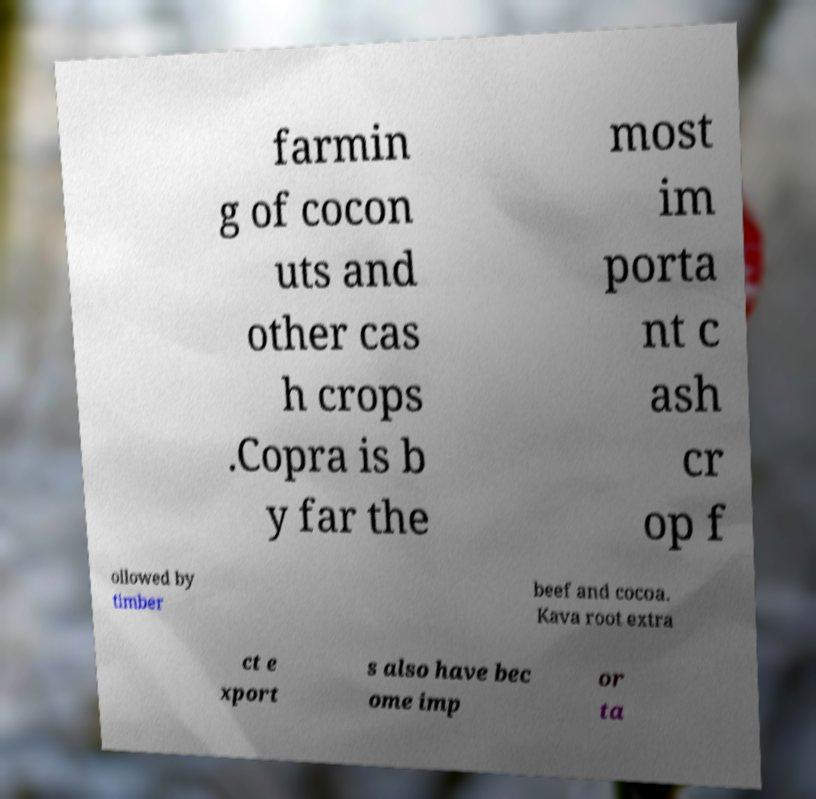Can you accurately transcribe the text from the provided image for me? farmin g of cocon uts and other cas h crops .Copra is b y far the most im porta nt c ash cr op f ollowed by timber beef and cocoa. Kava root extra ct e xport s also have bec ome imp or ta 